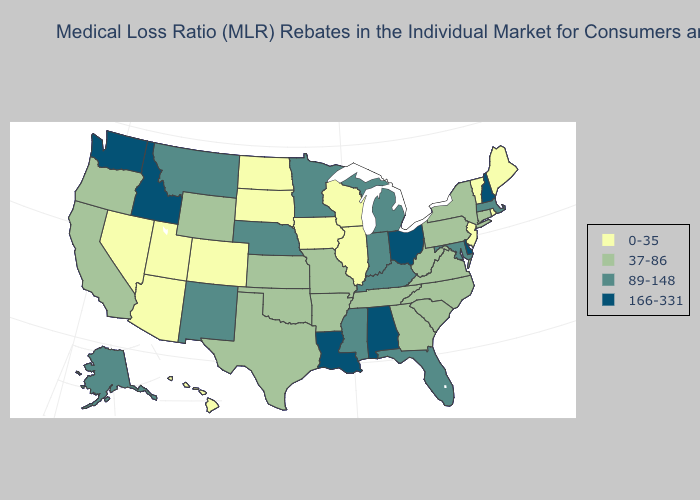Name the states that have a value in the range 37-86?
Concise answer only. Arkansas, California, Connecticut, Georgia, Kansas, Missouri, New York, North Carolina, Oklahoma, Oregon, Pennsylvania, South Carolina, Tennessee, Texas, Virginia, West Virginia, Wyoming. Which states have the lowest value in the USA?
Quick response, please. Arizona, Colorado, Hawaii, Illinois, Iowa, Maine, Nevada, New Jersey, North Dakota, Rhode Island, South Dakota, Utah, Vermont, Wisconsin. What is the highest value in the Northeast ?
Write a very short answer. 166-331. Does North Dakota have the highest value in the USA?
Give a very brief answer. No. Name the states that have a value in the range 37-86?
Short answer required. Arkansas, California, Connecticut, Georgia, Kansas, Missouri, New York, North Carolina, Oklahoma, Oregon, Pennsylvania, South Carolina, Tennessee, Texas, Virginia, West Virginia, Wyoming. Which states hav the highest value in the West?
Concise answer only. Idaho, Washington. Does the map have missing data?
Short answer required. No. Does Minnesota have the lowest value in the USA?
Concise answer only. No. How many symbols are there in the legend?
Give a very brief answer. 4. Does Alaska have a lower value than Mississippi?
Short answer required. No. Name the states that have a value in the range 0-35?
Be succinct. Arizona, Colorado, Hawaii, Illinois, Iowa, Maine, Nevada, New Jersey, North Dakota, Rhode Island, South Dakota, Utah, Vermont, Wisconsin. How many symbols are there in the legend?
Short answer required. 4. Does Idaho have the highest value in the West?
Short answer required. Yes. Does Montana have the highest value in the West?
Give a very brief answer. No. What is the value of Rhode Island?
Answer briefly. 0-35. 